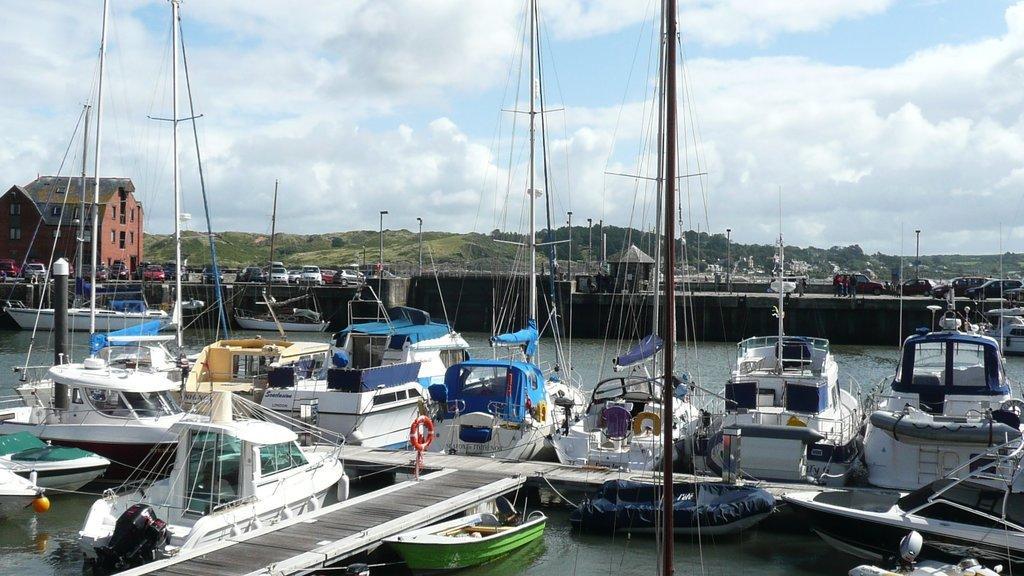Could you give a brief overview of what you see in this image? In this image, we can see few ships which are drowning on the water. In the background, we can see a bridge, vehicles, building, glass window, trees, plants, street lights, electric pole. At the top, we can see a sky which is a bit cloudy, at the bottom, we can see a water in a lake. 